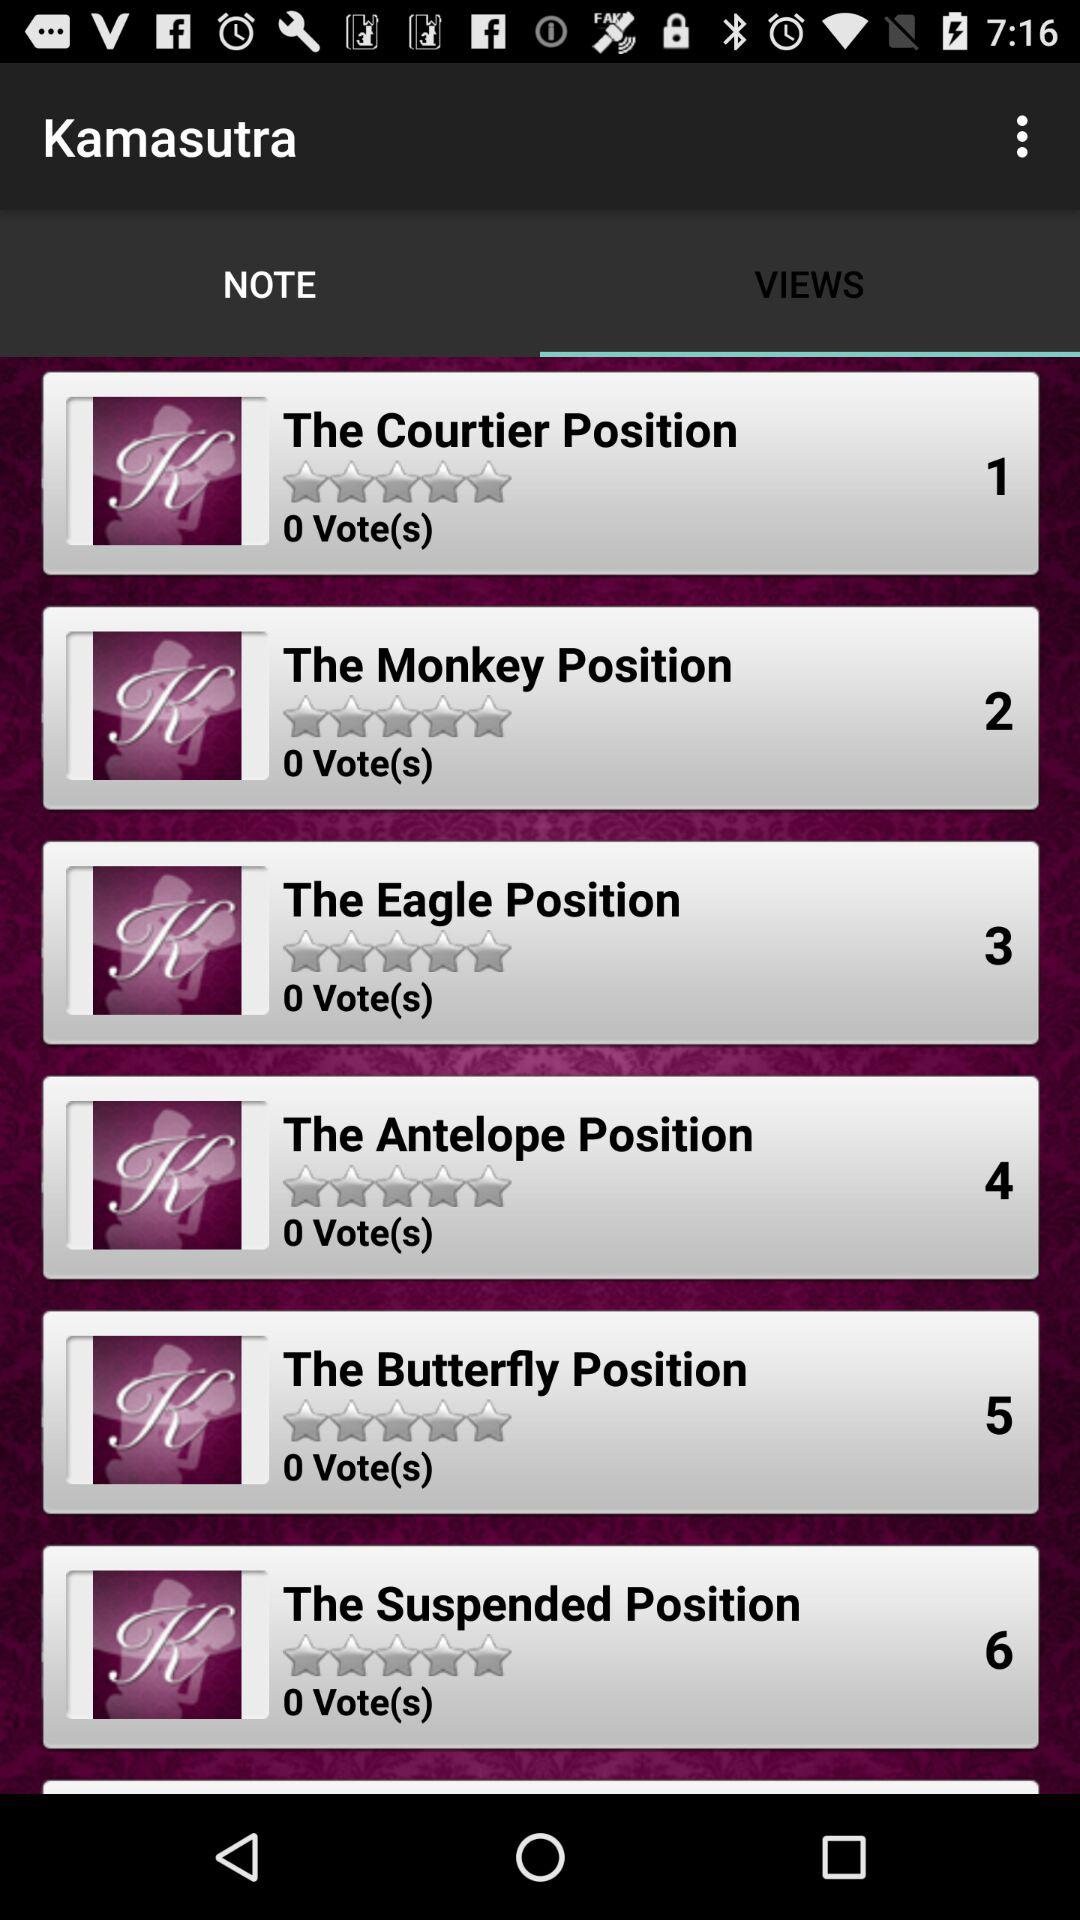Which tab is selected? The selected tab is "VIEWS". 